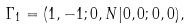<formula> <loc_0><loc_0><loc_500><loc_500>\Gamma _ { 1 } = ( 1 , - 1 ; 0 , N | 0 , 0 ; 0 , 0 ) ,</formula> 